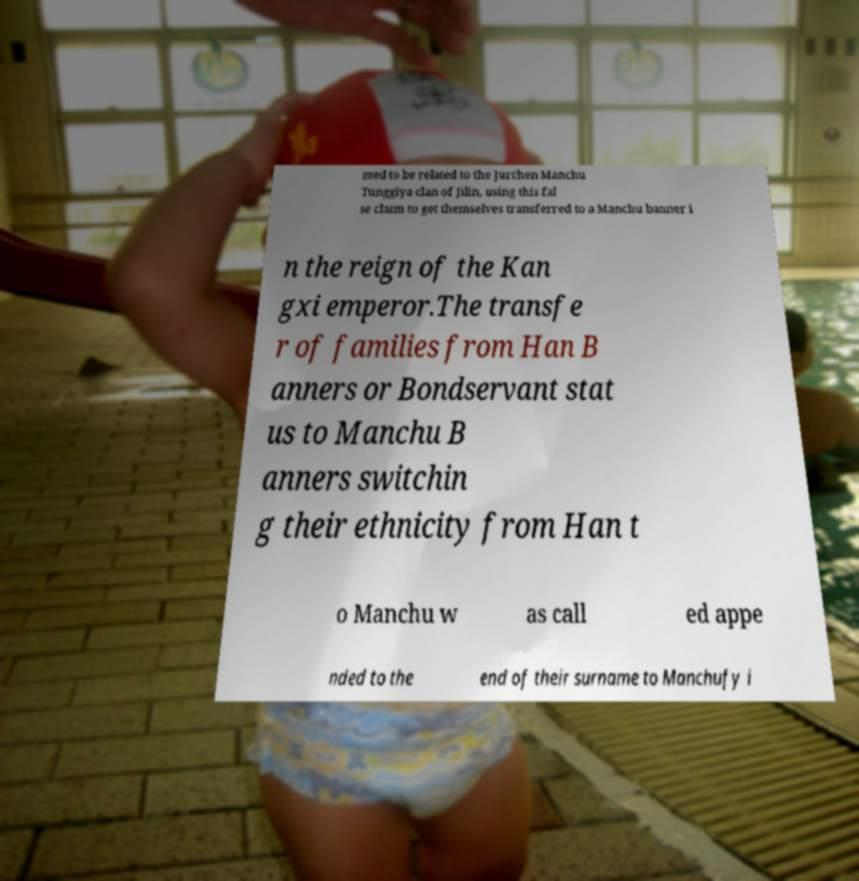Could you extract and type out the text from this image? med to be related to the Jurchen Manchu Tunggiya clan of Jilin, using this fal se claim to get themselves transferred to a Manchu banner i n the reign of the Kan gxi emperor.The transfe r of families from Han B anners or Bondservant stat us to Manchu B anners switchin g their ethnicity from Han t o Manchu w as call ed appe nded to the end of their surname to Manchufy i 